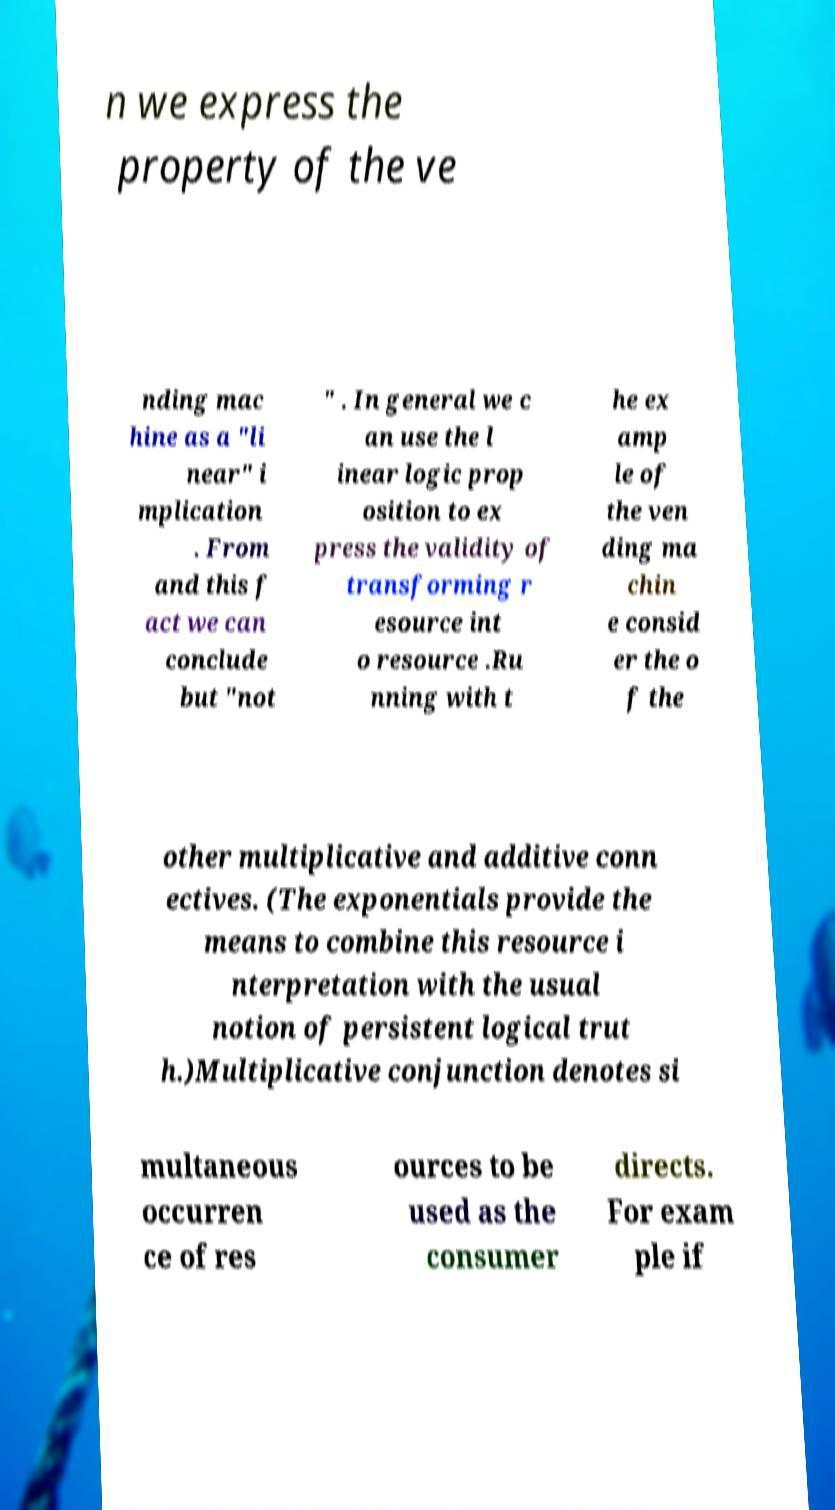Can you accurately transcribe the text from the provided image for me? n we express the property of the ve nding mac hine as a "li near" i mplication . From and this f act we can conclude but "not " . In general we c an use the l inear logic prop osition to ex press the validity of transforming r esource int o resource .Ru nning with t he ex amp le of the ven ding ma chin e consid er the o f the other multiplicative and additive conn ectives. (The exponentials provide the means to combine this resource i nterpretation with the usual notion of persistent logical trut h.)Multiplicative conjunction denotes si multaneous occurren ce of res ources to be used as the consumer directs. For exam ple if 